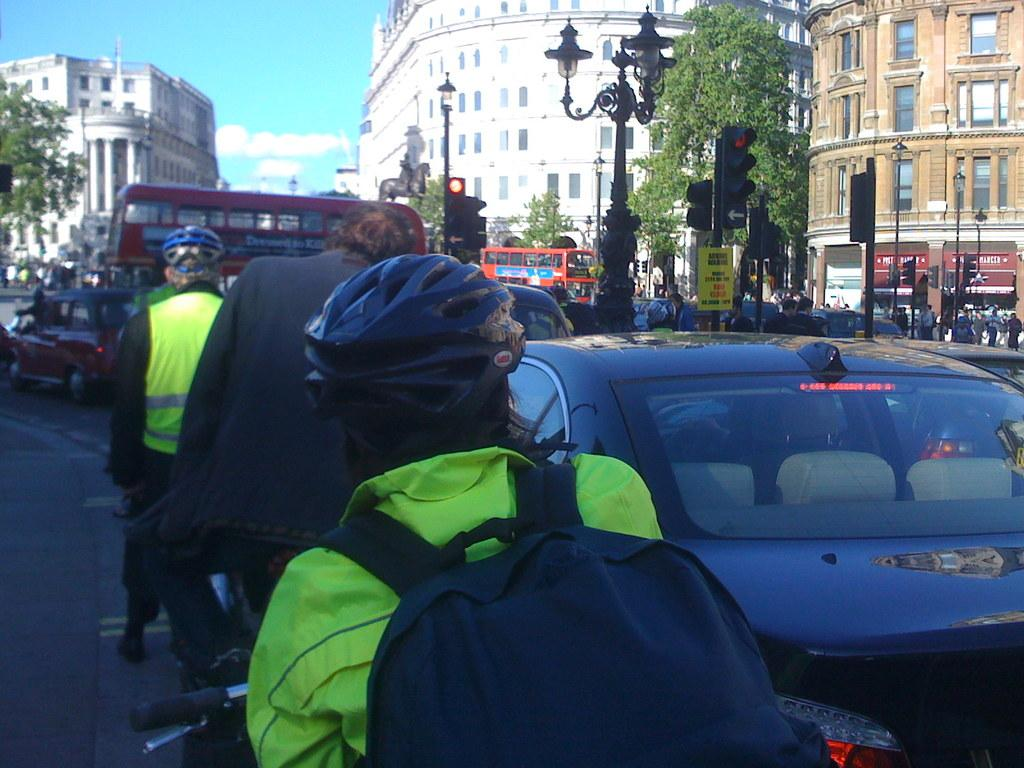What can be seen on the road in the image? There are vehicles and people on the road in the image. What is visible in the background of the image? There are buildings, trees, light poles, and a statue in the background of the image. What part of the natural environment is visible in the image? The sky is visible in the image. What type of wire is being used to hold the statue in the image? There is no wire visible in the image holding the statue; it appears to be standing on its own. Who is the achiever depicted in the statue in the image? There is no information provided about the statue's subject, so it cannot be determined who the achiever is. 